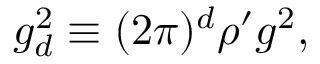Convert formula to latex. <formula><loc_0><loc_0><loc_500><loc_500>g _ { d } ^ { 2 } \equiv ( 2 \pi ) ^ { d } \rho ^ { \prime } g ^ { 2 } ,</formula> 